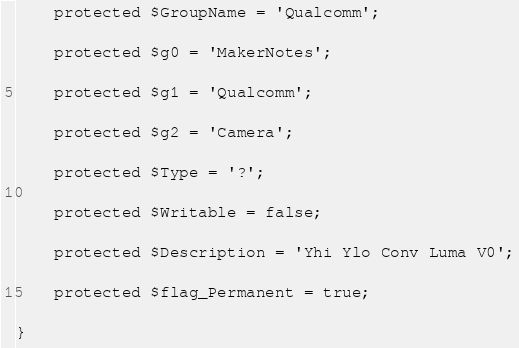Convert code to text. <code><loc_0><loc_0><loc_500><loc_500><_PHP_>
    protected $GroupName = 'Qualcomm';

    protected $g0 = 'MakerNotes';

    protected $g1 = 'Qualcomm';

    protected $g2 = 'Camera';

    protected $Type = '?';

    protected $Writable = false;

    protected $Description = 'Yhi Ylo Conv Luma V0';

    protected $flag_Permanent = true;

}
</code> 